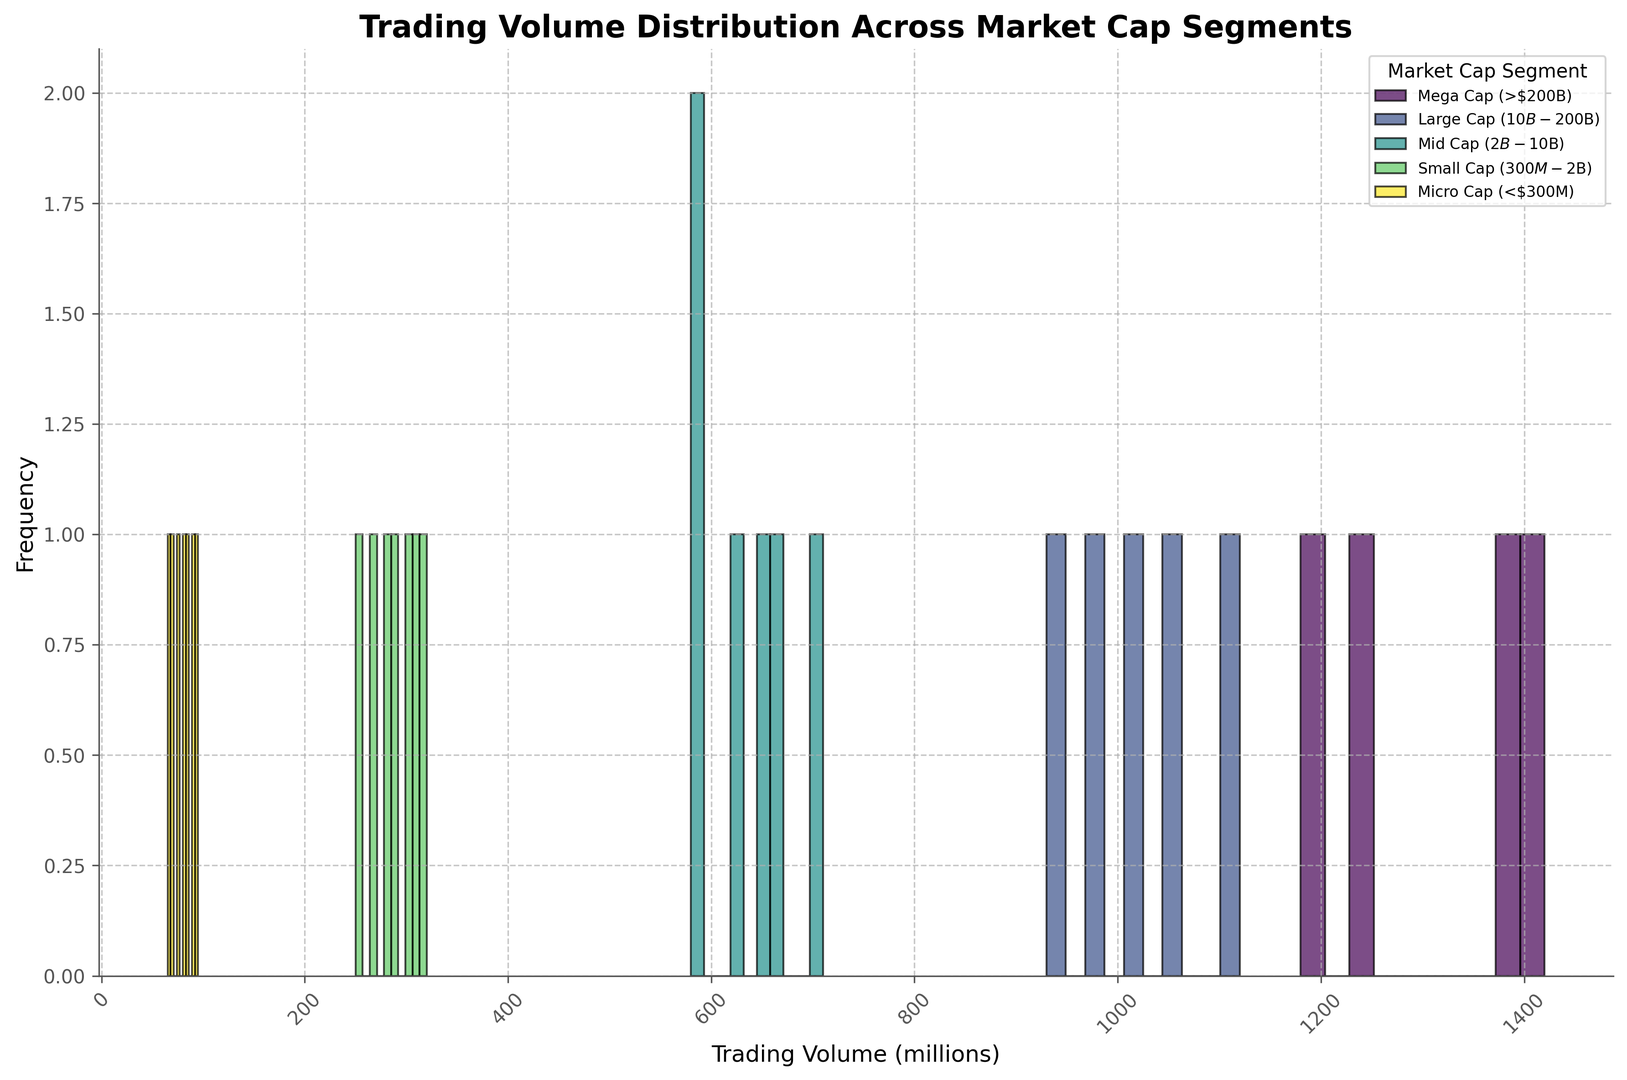Which Market Cap segment has the highest trading volume? The height of the bars representing frequencies shows which Market Cap segment has the highest trading volume. The Mega Cap segment has the highest bars, indicating that it has the highest trading volumes.
Answer: Mega Cap (>$200B) How does the trading volume of Large Cap compare to Mid Cap? By comparing the positions and frequencies of the bins for Large Cap and Mid Cap segments, we can see that the Large Cap's trading volumes generally range higher than those of Mid Cap. The Large Cap bins are centered around higher values than those of Mid Cap.
Answer: Large Cap is higher than Mid Cap Which segment has the lowest trading volume? The height of the bars for each segment shows the trading volume distribution. The Micro Cap segment has the lower range of trading volumes as indicated by the bars situated at the lower range of the x-axis.
Answer: Micro Cap (<$300M) What is the range of trading volumes observed in the Small Cap segment? The bins representing the Small Cap segment show trading volume values. The trading volumes for the Small Cap segments range approximately from 250 to 320 million.
Answer: 250 to 320 million Which segment shows the widest range of trading volumes? By looking at the range of trading volumes on the x-axis for each segment, the Mega Cap segment spans the furthest on the axis, indicating the widest range of trading volumes.
Answer: Mega Cap (>$200B) What is the median trading volume of the Mid Cap segment? Listing the Mid Cap trading volumes in ascending order: 580, 590, 620, 650, 670, 710 and identifying the middle value, 620, 650, 670 are the center values, hence (620 + 650) / 2 = 635 million is the median.
Answer: 635 million Which segments overlap in their trading volume distributions? By observing the histogram, the trading volumes of Large Cap and Mid Cap segments show overlap because some bars of both segments are at similar positions along the x-axis.
Answer: Large and Mid Cap How does the frequency of trading volume in the Small Cap segment compare to other segments? By examining the height of the bars representing each segment, the Small Cap segment shows lower frequencies compared to Large Cap and Mega Cap but higher than Micro Cap segment.
Answer: Lower than Mega and Large Cap, higher than Micro Cap What is the most frequent trading volume range in the Mega Cap segment? By looking at the bars representing the Mega Cap, the highest bars (frequency) are centered around the 1200-1400 million range, indicating the most frequent trading volume.
Answer: 1200-1400 million 